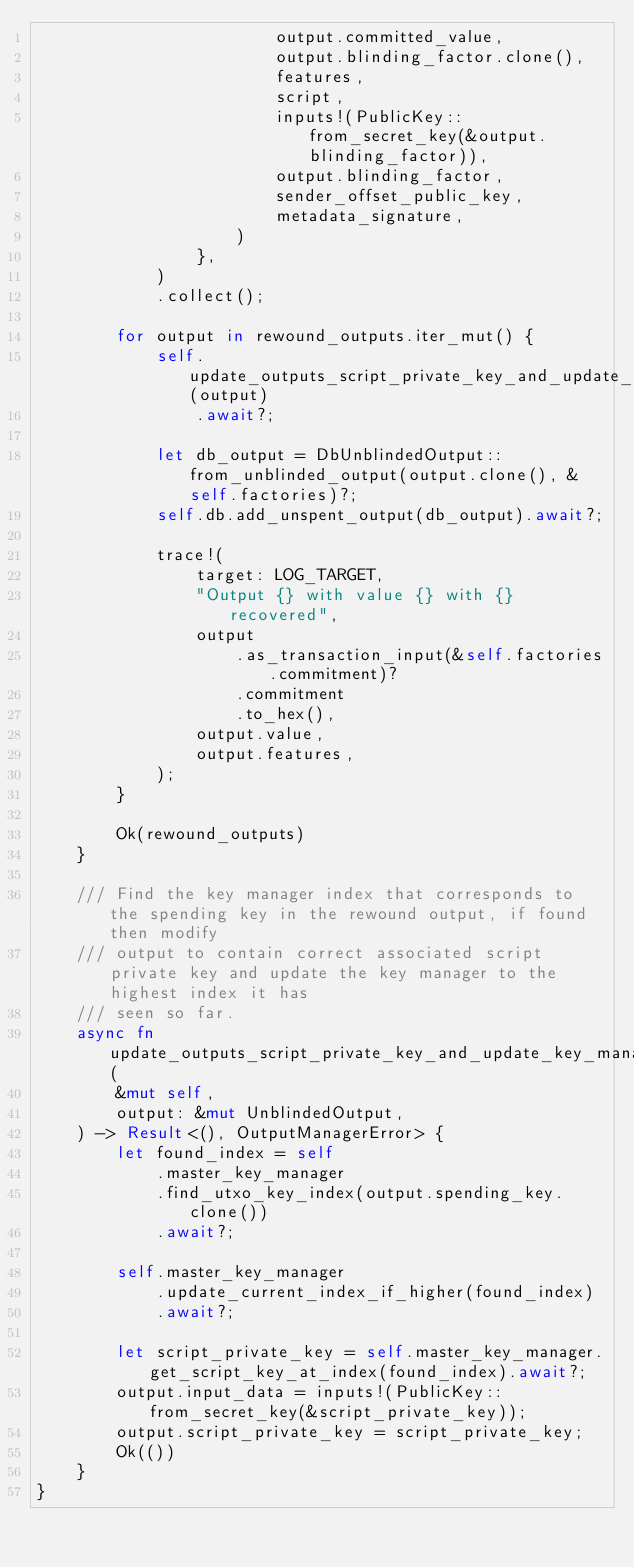Convert code to text. <code><loc_0><loc_0><loc_500><loc_500><_Rust_>                        output.committed_value,
                        output.blinding_factor.clone(),
                        features,
                        script,
                        inputs!(PublicKey::from_secret_key(&output.blinding_factor)),
                        output.blinding_factor,
                        sender_offset_public_key,
                        metadata_signature,
                    )
                },
            )
            .collect();

        for output in rewound_outputs.iter_mut() {
            self.update_outputs_script_private_key_and_update_key_manager_index(output)
                .await?;

            let db_output = DbUnblindedOutput::from_unblinded_output(output.clone(), &self.factories)?;
            self.db.add_unspent_output(db_output).await?;

            trace!(
                target: LOG_TARGET,
                "Output {} with value {} with {} recovered",
                output
                    .as_transaction_input(&self.factories.commitment)?
                    .commitment
                    .to_hex(),
                output.value,
                output.features,
            );
        }

        Ok(rewound_outputs)
    }

    /// Find the key manager index that corresponds to the spending key in the rewound output, if found then modify
    /// output to contain correct associated script private key and update the key manager to the highest index it has
    /// seen so far.
    async fn update_outputs_script_private_key_and_update_key_manager_index(
        &mut self,
        output: &mut UnblindedOutput,
    ) -> Result<(), OutputManagerError> {
        let found_index = self
            .master_key_manager
            .find_utxo_key_index(output.spending_key.clone())
            .await?;

        self.master_key_manager
            .update_current_index_if_higher(found_index)
            .await?;

        let script_private_key = self.master_key_manager.get_script_key_at_index(found_index).await?;
        output.input_data = inputs!(PublicKey::from_secret_key(&script_private_key));
        output.script_private_key = script_private_key;
        Ok(())
    }
}
</code> 